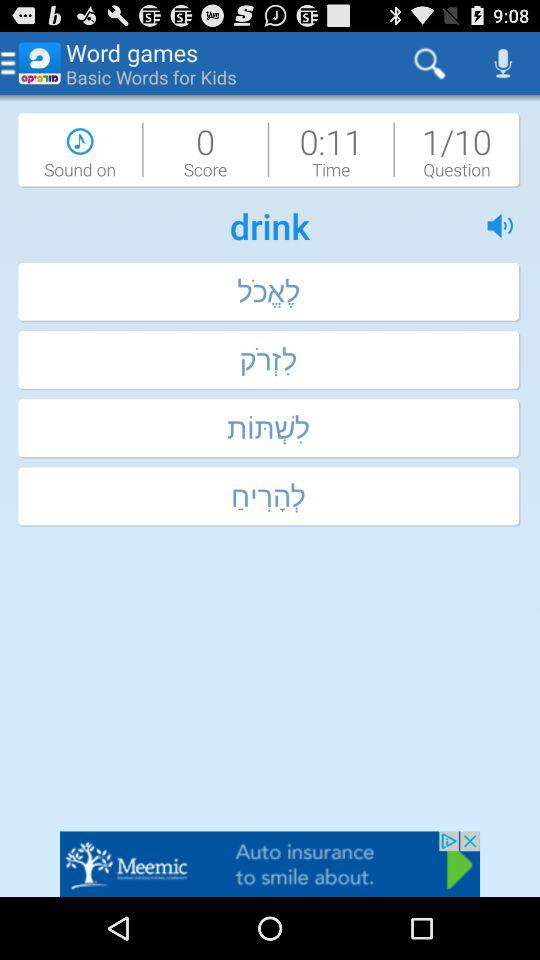What is the remaining time? The remaining time is 11 seconds. 